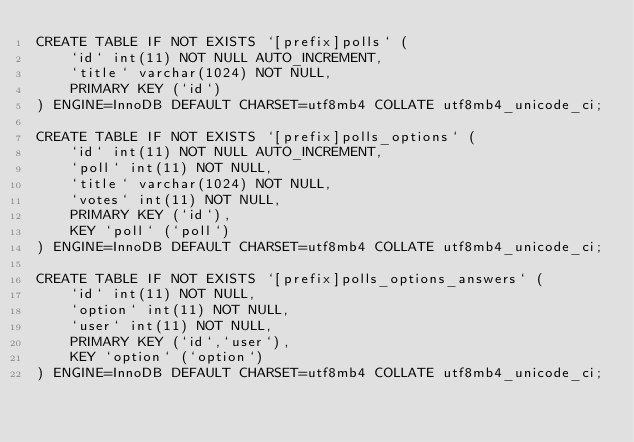<code> <loc_0><loc_0><loc_500><loc_500><_SQL_>CREATE TABLE IF NOT EXISTS `[prefix]polls` (
	`id` int(11) NOT NULL AUTO_INCREMENT,
	`title` varchar(1024) NOT NULL,
	PRIMARY KEY (`id`)
) ENGINE=InnoDB DEFAULT CHARSET=utf8mb4 COLLATE utf8mb4_unicode_ci;

CREATE TABLE IF NOT EXISTS `[prefix]polls_options` (
	`id` int(11) NOT NULL AUTO_INCREMENT,
	`poll` int(11) NOT NULL,
	`title` varchar(1024) NOT NULL,
	`votes` int(11) NOT NULL,
	PRIMARY KEY (`id`),
	KEY `poll` (`poll`)
) ENGINE=InnoDB DEFAULT CHARSET=utf8mb4 COLLATE utf8mb4_unicode_ci;

CREATE TABLE IF NOT EXISTS `[prefix]polls_options_answers` (
	`id` int(11) NOT NULL,
	`option` int(11) NOT NULL,
	`user` int(11) NOT NULL,
	PRIMARY KEY (`id`,`user`),
	KEY `option` (`option`)
) ENGINE=InnoDB DEFAULT CHARSET=utf8mb4 COLLATE utf8mb4_unicode_ci;
</code> 